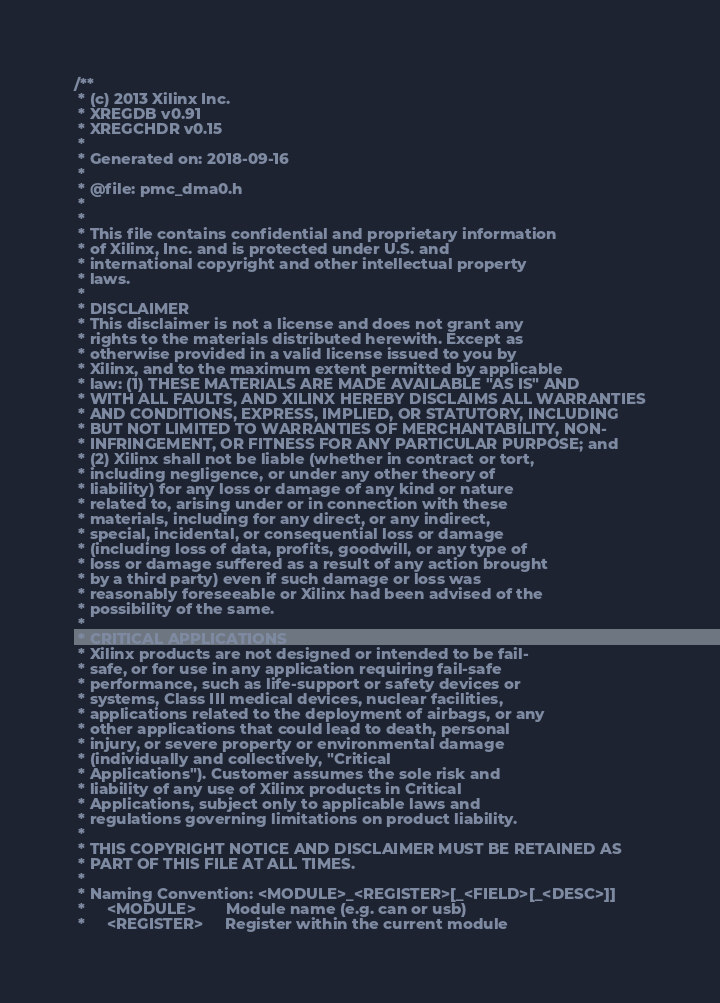Convert code to text. <code><loc_0><loc_0><loc_500><loc_500><_C_>/**
 * (c) 2013 Xilinx Inc.
 * XREGDB v0.91
 * XREGCHDR v0.15
 *
 * Generated on: 2018-09-16
 *
 * @file: pmc_dma0.h
 *
 *
 * This file contains confidential and proprietary information
 * of Xilinx, Inc. and is protected under U.S. and
 * international copyright and other intellectual property
 * laws.
 *
 * DISCLAIMER
 * This disclaimer is not a license and does not grant any
 * rights to the materials distributed herewith. Except as
 * otherwise provided in a valid license issued to you by
 * Xilinx, and to the maximum extent permitted by applicable
 * law: (1) THESE MATERIALS ARE MADE AVAILABLE "AS IS" AND
 * WITH ALL FAULTS, AND XILINX HEREBY DISCLAIMS ALL WARRANTIES
 * AND CONDITIONS, EXPRESS, IMPLIED, OR STATUTORY, INCLUDING
 * BUT NOT LIMITED TO WARRANTIES OF MERCHANTABILITY, NON-
 * INFRINGEMENT, OR FITNESS FOR ANY PARTICULAR PURPOSE; and
 * (2) Xilinx shall not be liable (whether in contract or tort,
 * including negligence, or under any other theory of
 * liability) for any loss or damage of any kind or nature
 * related to, arising under or in connection with these
 * materials, including for any direct, or any indirect,
 * special, incidental, or consequential loss or damage
 * (including loss of data, profits, goodwill, or any type of
 * loss or damage suffered as a result of any action brought
 * by a third party) even if such damage or loss was
 * reasonably foreseeable or Xilinx had been advised of the
 * possibility of the same.
 *
 * CRITICAL APPLICATIONS
 * Xilinx products are not designed or intended to be fail-
 * safe, or for use in any application requiring fail-safe
 * performance, such as life-support or safety devices or
 * systems, Class III medical devices, nuclear facilities,
 * applications related to the deployment of airbags, or any
 * other applications that could lead to death, personal
 * injury, or severe property or environmental damage
 * (individually and collectively, "Critical
 * Applications"). Customer assumes the sole risk and
 * liability of any use of Xilinx products in Critical
 * Applications, subject only to applicable laws and
 * regulations governing limitations on product liability.
 *
 * THIS COPYRIGHT NOTICE AND DISCLAIMER MUST BE RETAINED AS
 * PART OF THIS FILE AT ALL TIMES.
 *
 * Naming Convention: <MODULE>_<REGISTER>[_<FIELD>[_<DESC>]]
 *     <MODULE>       Module name (e.g. can or usb)
 *     <REGISTER>     Register within the current module</code> 